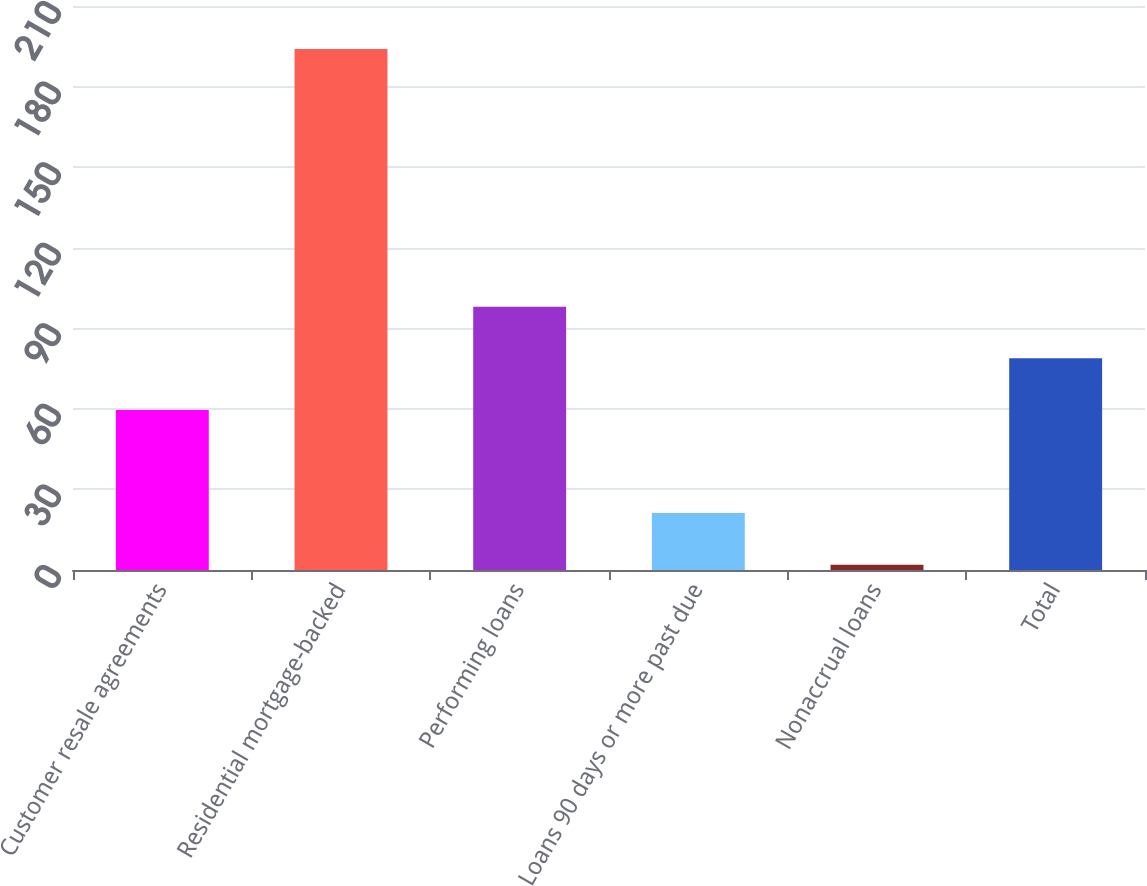<chart> <loc_0><loc_0><loc_500><loc_500><bar_chart><fcel>Customer resale agreements<fcel>Residential mortgage-backed<fcel>Performing loans<fcel>Loans 90 days or more past due<fcel>Nonaccrual loans<fcel>Total<nl><fcel>59.6<fcel>194<fcel>98<fcel>21.2<fcel>2<fcel>78.8<nl></chart> 